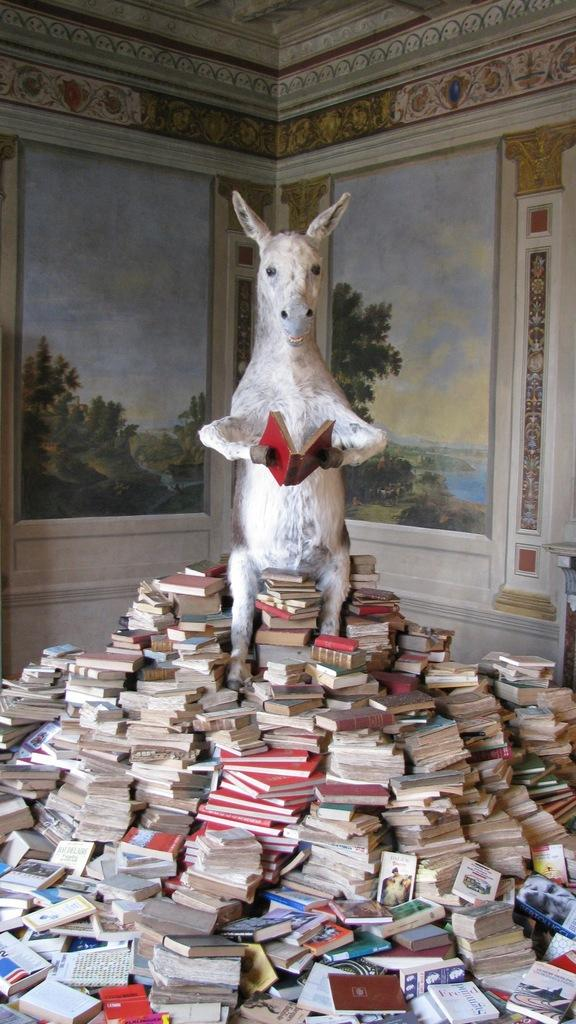What can be seen on the wall in the background of the image? There is a painting on the wall in the background of the image. What is the design of the wall? The wall has a designed pattern or texture. What is the statue holding in the image? The statue is holding a book. What is surrounding the statue in the image? The statue is surrounded by books. What type of plastic material is used to create the books surrounding the statue? There is no mention of plastic material in the image; the books are likely made of paper or other traditional materials. Is there a spy observing the statue in the image? There is no indication of a spy or any person in the image; it only features a statue and books. 